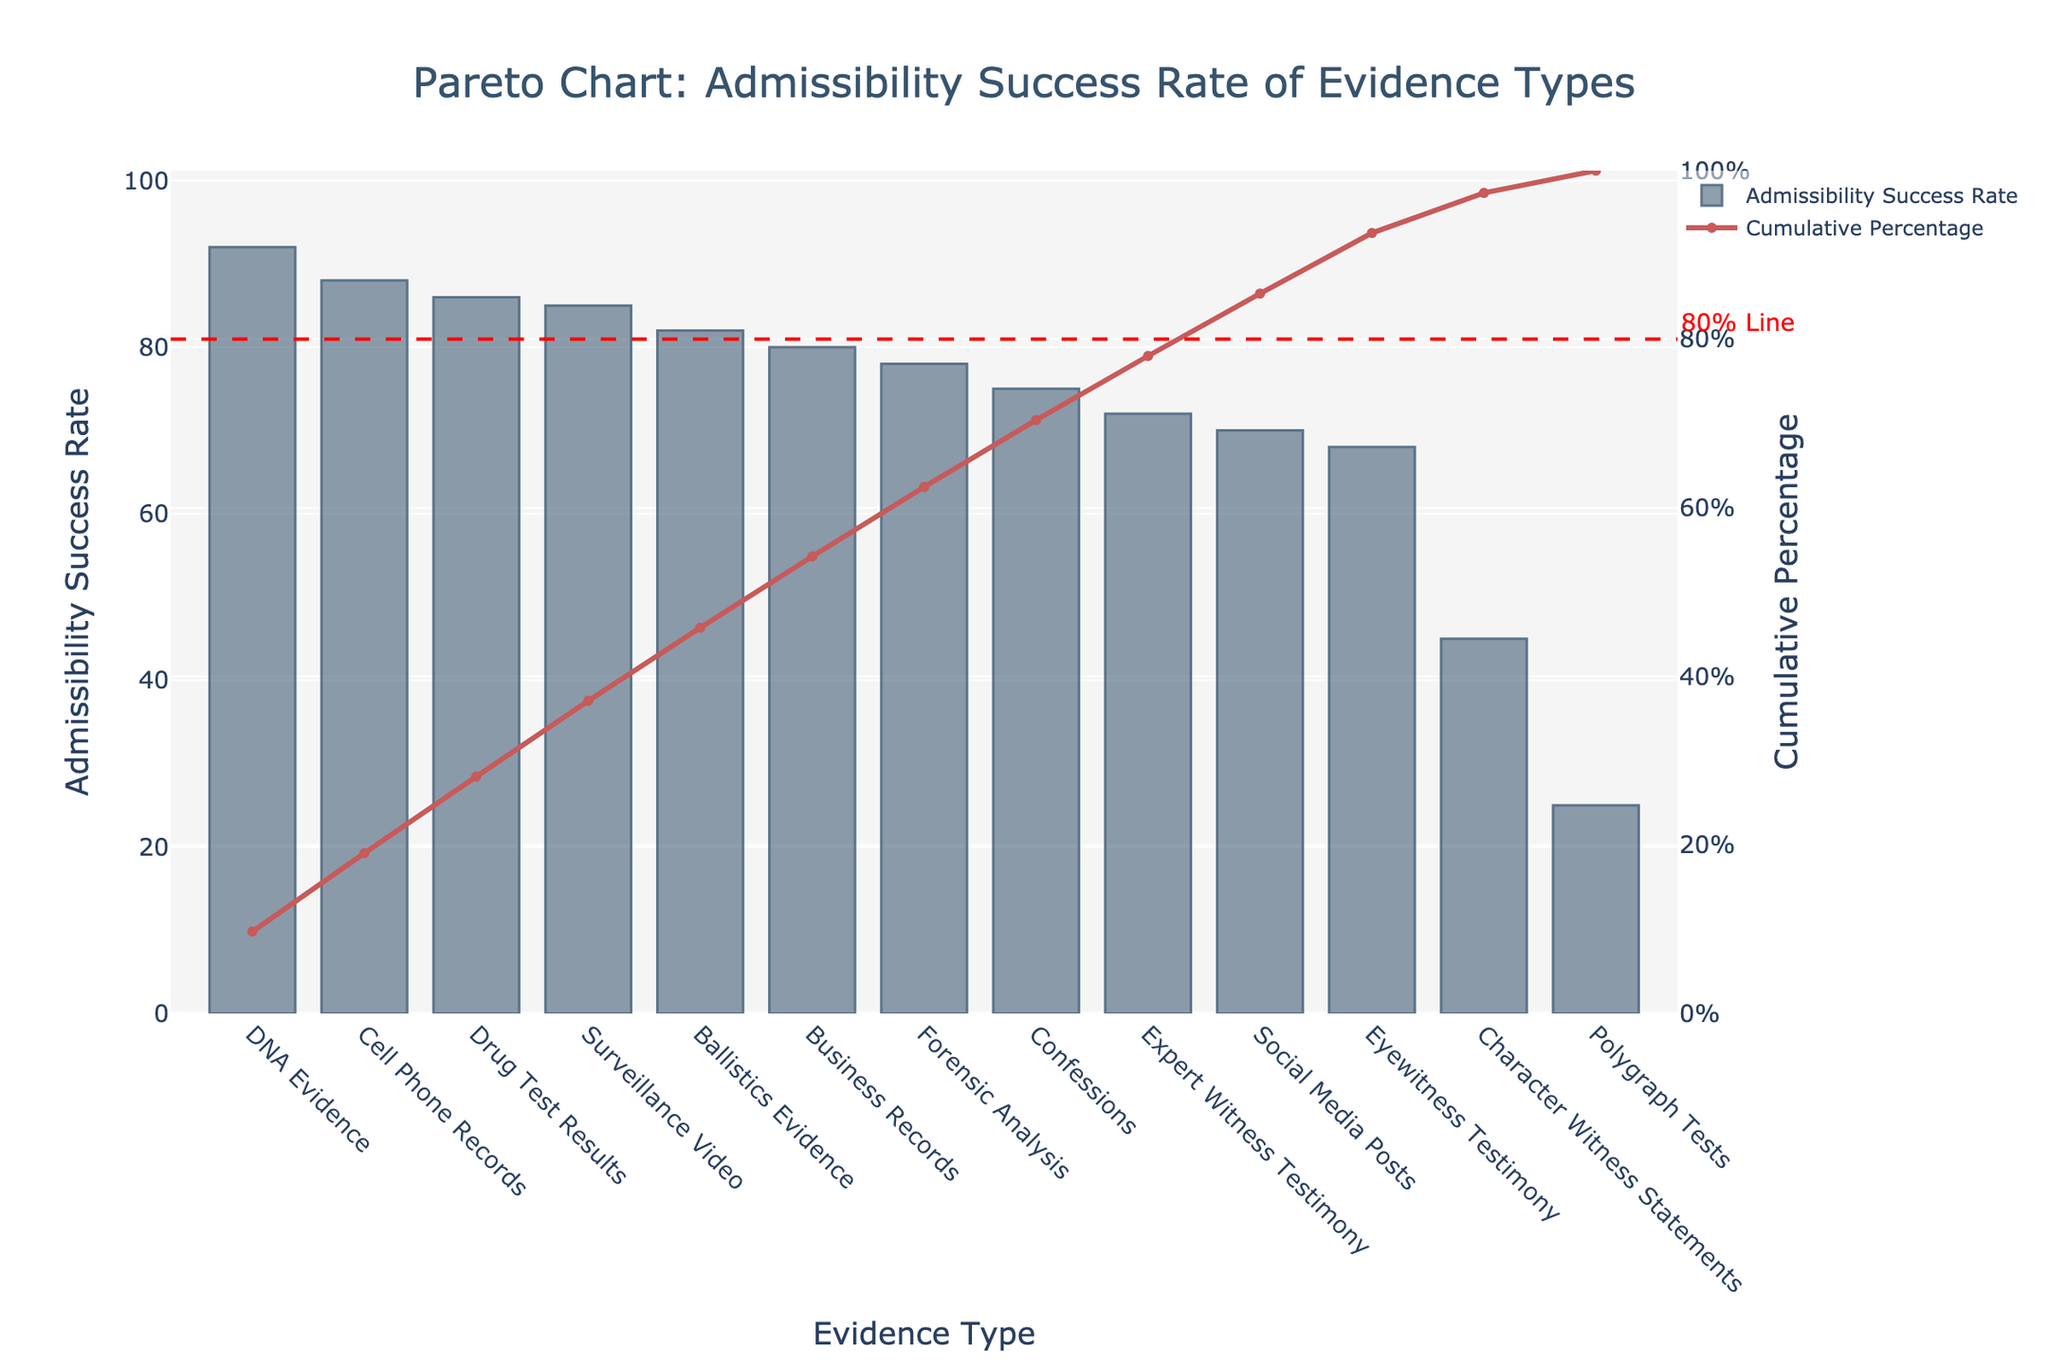What is the title of the figure? The title is usually found at the top of the figure and provides a summary of what the figure is about.
Answer: Pareto Chart: Admissibility Success Rate of Evidence Types Which evidence type has the highest admissibility success rate? The highest bar in the chart represents the evidence type with the highest admissibility success rate.
Answer: DNA Evidence What is the admissibility success rate of eyewitness testimony? Look for the bar labeled 'Eyewitness Testimony' and check its height against the left y-axis.
Answer: 68 How many evidence types have an admissibility success rate above 80%? Identify all the bars above the 80% mark on the left y-axis (bars of DNA Evidence, Cell Phone Records, Surveillance Video, Ballistics Evidence, and Drug Test Results).
Answer: 5 Is the cumulative percentage for social media posts above or below 60%? Find the line corresponding to 'Social Media Posts' and see where it intersects on the right y-axis (cumulative percentage).
Answer: Below How does the admissibility success rate of polygraph tests compare to that of character witness statements? Compare the heights of the bars labeled 'Polygraph Tests' and 'Character Witness Statements' against the left y-axis.
Answer: Lower Which evidence type contributes the most to the cumulative percentage around the 80% threshold? Identify the segment where the cumulative percentage line crosses the 80% mark and check the evidence type around that point.
Answer: Ballistics Evidence What percentage does the cumulative line reach at forensics analysis? Look at where the cumulative percentage line meets the evidence type 'Forensic Analysis' and refer to the right y-axis.
Answer: Approximately 67% Which evidence type has the lowest admissibility success rate? Find the bar with the least height against the left y-axis.
Answer: Polygraph Tests What is the difference in admissibility success rates between confessions and social media posts? Subtract the height of the bar for 'Social Media Posts' from the height of the bar for 'Confessions' using the left y-axis values (75 - 70).
Answer: 5 